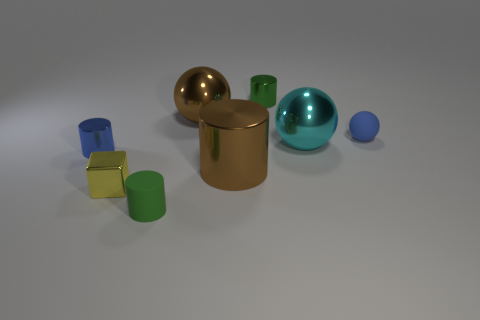Is there any other thing that is the same shape as the green metal thing?
Make the answer very short. Yes. What is the shape of the green object that is behind the cylinder that is in front of the tiny shiny cube?
Ensure brevity in your answer.  Cylinder. There is a green object that is made of the same material as the tiny yellow object; what is its shape?
Keep it short and to the point. Cylinder. What size is the sphere that is left of the green thing that is to the right of the green matte object?
Provide a succinct answer. Large. The tiny green rubber object has what shape?
Offer a terse response. Cylinder. What number of tiny things are cyan spheres or metal spheres?
Give a very brief answer. 0. What size is the other matte thing that is the same shape as the cyan thing?
Your answer should be very brief. Small. What number of tiny cylinders are on the right side of the small blue cylinder and behind the green rubber thing?
Ensure brevity in your answer.  1. Do the small green metal object and the brown shiny thing behind the small sphere have the same shape?
Keep it short and to the point. No. Are there more big spheres left of the tiny sphere than large brown objects?
Give a very brief answer. No. 